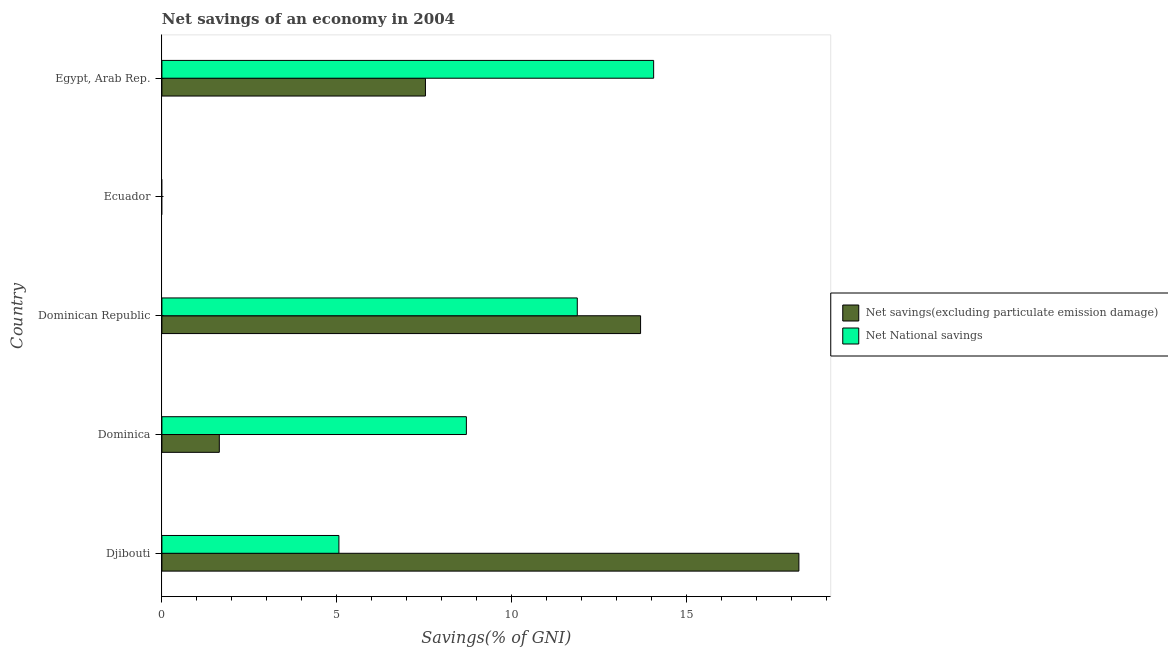How many different coloured bars are there?
Your response must be concise. 2. Are the number of bars per tick equal to the number of legend labels?
Offer a terse response. No. Are the number of bars on each tick of the Y-axis equal?
Offer a terse response. No. How many bars are there on the 1st tick from the top?
Offer a very short reply. 2. What is the label of the 3rd group of bars from the top?
Offer a terse response. Dominican Republic. In how many cases, is the number of bars for a given country not equal to the number of legend labels?
Keep it short and to the point. 1. What is the net savings(excluding particulate emission damage) in Djibouti?
Provide a succinct answer. 18.22. Across all countries, what is the maximum net savings(excluding particulate emission damage)?
Your answer should be compact. 18.22. In which country was the net national savings maximum?
Give a very brief answer. Egypt, Arab Rep. What is the total net savings(excluding particulate emission damage) in the graph?
Provide a short and direct response. 41.08. What is the difference between the net national savings in Dominica and that in Egypt, Arab Rep.?
Your answer should be very brief. -5.36. What is the difference between the net savings(excluding particulate emission damage) in Ecuador and the net national savings in Dominican Republic?
Keep it short and to the point. -11.88. What is the average net savings(excluding particulate emission damage) per country?
Provide a short and direct response. 8.22. What is the difference between the net national savings and net savings(excluding particulate emission damage) in Dominican Republic?
Keep it short and to the point. -1.81. In how many countries, is the net savings(excluding particulate emission damage) greater than 4 %?
Your answer should be very brief. 3. What is the ratio of the net savings(excluding particulate emission damage) in Dominica to that in Dominican Republic?
Ensure brevity in your answer.  0.12. Is the difference between the net savings(excluding particulate emission damage) in Djibouti and Dominican Republic greater than the difference between the net national savings in Djibouti and Dominican Republic?
Offer a terse response. Yes. What is the difference between the highest and the second highest net savings(excluding particulate emission damage)?
Your answer should be very brief. 4.53. What is the difference between the highest and the lowest net savings(excluding particulate emission damage)?
Provide a short and direct response. 18.22. Is the sum of the net national savings in Dominica and Dominican Republic greater than the maximum net savings(excluding particulate emission damage) across all countries?
Keep it short and to the point. Yes. How many bars are there?
Make the answer very short. 8. Are all the bars in the graph horizontal?
Offer a very short reply. Yes. Does the graph contain any zero values?
Make the answer very short. Yes. Does the graph contain grids?
Ensure brevity in your answer.  No. How many legend labels are there?
Your answer should be compact. 2. What is the title of the graph?
Offer a very short reply. Net savings of an economy in 2004. What is the label or title of the X-axis?
Keep it short and to the point. Savings(% of GNI). What is the label or title of the Y-axis?
Offer a very short reply. Country. What is the Savings(% of GNI) in Net savings(excluding particulate emission damage) in Djibouti?
Your answer should be compact. 18.22. What is the Savings(% of GNI) of Net National savings in Djibouti?
Your answer should be very brief. 5.06. What is the Savings(% of GNI) in Net savings(excluding particulate emission damage) in Dominica?
Your response must be concise. 1.64. What is the Savings(% of GNI) of Net National savings in Dominica?
Keep it short and to the point. 8.71. What is the Savings(% of GNI) of Net savings(excluding particulate emission damage) in Dominican Republic?
Give a very brief answer. 13.69. What is the Savings(% of GNI) in Net National savings in Dominican Republic?
Provide a succinct answer. 11.88. What is the Savings(% of GNI) in Net savings(excluding particulate emission damage) in Egypt, Arab Rep.?
Provide a succinct answer. 7.54. What is the Savings(% of GNI) of Net National savings in Egypt, Arab Rep.?
Offer a very short reply. 14.06. Across all countries, what is the maximum Savings(% of GNI) in Net savings(excluding particulate emission damage)?
Make the answer very short. 18.22. Across all countries, what is the maximum Savings(% of GNI) in Net National savings?
Offer a very short reply. 14.06. Across all countries, what is the minimum Savings(% of GNI) in Net savings(excluding particulate emission damage)?
Offer a terse response. 0. What is the total Savings(% of GNI) of Net savings(excluding particulate emission damage) in the graph?
Offer a very short reply. 41.08. What is the total Savings(% of GNI) of Net National savings in the graph?
Give a very brief answer. 39.71. What is the difference between the Savings(% of GNI) in Net savings(excluding particulate emission damage) in Djibouti and that in Dominica?
Provide a succinct answer. 16.57. What is the difference between the Savings(% of GNI) of Net National savings in Djibouti and that in Dominica?
Your answer should be compact. -3.65. What is the difference between the Savings(% of GNI) in Net savings(excluding particulate emission damage) in Djibouti and that in Dominican Republic?
Your answer should be very brief. 4.53. What is the difference between the Savings(% of GNI) of Net National savings in Djibouti and that in Dominican Republic?
Provide a short and direct response. -6.82. What is the difference between the Savings(% of GNI) of Net savings(excluding particulate emission damage) in Djibouti and that in Egypt, Arab Rep.?
Offer a very short reply. 10.68. What is the difference between the Savings(% of GNI) in Net National savings in Djibouti and that in Egypt, Arab Rep.?
Your response must be concise. -9. What is the difference between the Savings(% of GNI) in Net savings(excluding particulate emission damage) in Dominica and that in Dominican Republic?
Provide a succinct answer. -12.05. What is the difference between the Savings(% of GNI) in Net National savings in Dominica and that in Dominican Republic?
Offer a very short reply. -3.17. What is the difference between the Savings(% of GNI) in Net savings(excluding particulate emission damage) in Dominica and that in Egypt, Arab Rep.?
Your response must be concise. -5.89. What is the difference between the Savings(% of GNI) of Net National savings in Dominica and that in Egypt, Arab Rep.?
Your answer should be very brief. -5.36. What is the difference between the Savings(% of GNI) in Net savings(excluding particulate emission damage) in Dominican Republic and that in Egypt, Arab Rep.?
Provide a short and direct response. 6.15. What is the difference between the Savings(% of GNI) of Net National savings in Dominican Republic and that in Egypt, Arab Rep.?
Offer a terse response. -2.18. What is the difference between the Savings(% of GNI) in Net savings(excluding particulate emission damage) in Djibouti and the Savings(% of GNI) in Net National savings in Dominica?
Your answer should be very brief. 9.51. What is the difference between the Savings(% of GNI) of Net savings(excluding particulate emission damage) in Djibouti and the Savings(% of GNI) of Net National savings in Dominican Republic?
Keep it short and to the point. 6.34. What is the difference between the Savings(% of GNI) of Net savings(excluding particulate emission damage) in Djibouti and the Savings(% of GNI) of Net National savings in Egypt, Arab Rep.?
Provide a short and direct response. 4.15. What is the difference between the Savings(% of GNI) in Net savings(excluding particulate emission damage) in Dominica and the Savings(% of GNI) in Net National savings in Dominican Republic?
Your answer should be compact. -10.24. What is the difference between the Savings(% of GNI) of Net savings(excluding particulate emission damage) in Dominica and the Savings(% of GNI) of Net National savings in Egypt, Arab Rep.?
Ensure brevity in your answer.  -12.42. What is the difference between the Savings(% of GNI) of Net savings(excluding particulate emission damage) in Dominican Republic and the Savings(% of GNI) of Net National savings in Egypt, Arab Rep.?
Provide a short and direct response. -0.37. What is the average Savings(% of GNI) of Net savings(excluding particulate emission damage) per country?
Keep it short and to the point. 8.22. What is the average Savings(% of GNI) of Net National savings per country?
Your answer should be compact. 7.94. What is the difference between the Savings(% of GNI) of Net savings(excluding particulate emission damage) and Savings(% of GNI) of Net National savings in Djibouti?
Provide a succinct answer. 13.15. What is the difference between the Savings(% of GNI) of Net savings(excluding particulate emission damage) and Savings(% of GNI) of Net National savings in Dominica?
Provide a short and direct response. -7.06. What is the difference between the Savings(% of GNI) of Net savings(excluding particulate emission damage) and Savings(% of GNI) of Net National savings in Dominican Republic?
Offer a very short reply. 1.81. What is the difference between the Savings(% of GNI) in Net savings(excluding particulate emission damage) and Savings(% of GNI) in Net National savings in Egypt, Arab Rep.?
Your answer should be compact. -6.53. What is the ratio of the Savings(% of GNI) in Net savings(excluding particulate emission damage) in Djibouti to that in Dominica?
Provide a succinct answer. 11.09. What is the ratio of the Savings(% of GNI) in Net National savings in Djibouti to that in Dominica?
Keep it short and to the point. 0.58. What is the ratio of the Savings(% of GNI) of Net savings(excluding particulate emission damage) in Djibouti to that in Dominican Republic?
Offer a terse response. 1.33. What is the ratio of the Savings(% of GNI) in Net National savings in Djibouti to that in Dominican Republic?
Ensure brevity in your answer.  0.43. What is the ratio of the Savings(% of GNI) of Net savings(excluding particulate emission damage) in Djibouti to that in Egypt, Arab Rep.?
Ensure brevity in your answer.  2.42. What is the ratio of the Savings(% of GNI) of Net National savings in Djibouti to that in Egypt, Arab Rep.?
Give a very brief answer. 0.36. What is the ratio of the Savings(% of GNI) of Net savings(excluding particulate emission damage) in Dominica to that in Dominican Republic?
Offer a very short reply. 0.12. What is the ratio of the Savings(% of GNI) of Net National savings in Dominica to that in Dominican Republic?
Keep it short and to the point. 0.73. What is the ratio of the Savings(% of GNI) of Net savings(excluding particulate emission damage) in Dominica to that in Egypt, Arab Rep.?
Ensure brevity in your answer.  0.22. What is the ratio of the Savings(% of GNI) of Net National savings in Dominica to that in Egypt, Arab Rep.?
Your answer should be compact. 0.62. What is the ratio of the Savings(% of GNI) of Net savings(excluding particulate emission damage) in Dominican Republic to that in Egypt, Arab Rep.?
Provide a succinct answer. 1.82. What is the ratio of the Savings(% of GNI) of Net National savings in Dominican Republic to that in Egypt, Arab Rep.?
Your answer should be very brief. 0.84. What is the difference between the highest and the second highest Savings(% of GNI) in Net savings(excluding particulate emission damage)?
Keep it short and to the point. 4.53. What is the difference between the highest and the second highest Savings(% of GNI) in Net National savings?
Offer a very short reply. 2.18. What is the difference between the highest and the lowest Savings(% of GNI) in Net savings(excluding particulate emission damage)?
Give a very brief answer. 18.22. What is the difference between the highest and the lowest Savings(% of GNI) in Net National savings?
Your answer should be compact. 14.06. 